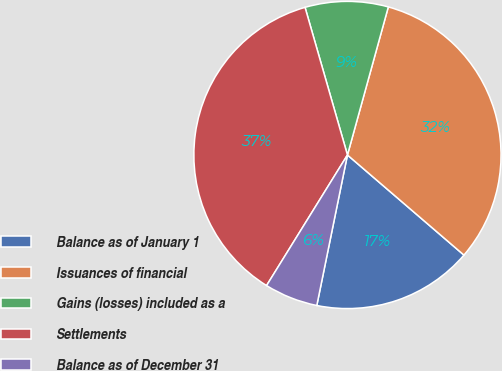Convert chart. <chart><loc_0><loc_0><loc_500><loc_500><pie_chart><fcel>Balance as of January 1<fcel>Issuances of financial<fcel>Gains (losses) included as a<fcel>Settlements<fcel>Balance as of December 31<nl><fcel>16.9%<fcel>32.01%<fcel>8.74%<fcel>36.72%<fcel>5.63%<nl></chart> 